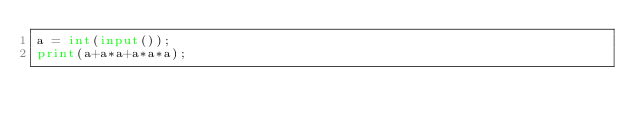<code> <loc_0><loc_0><loc_500><loc_500><_Python_>a = int(input());
print(a+a*a+a*a*a);</code> 